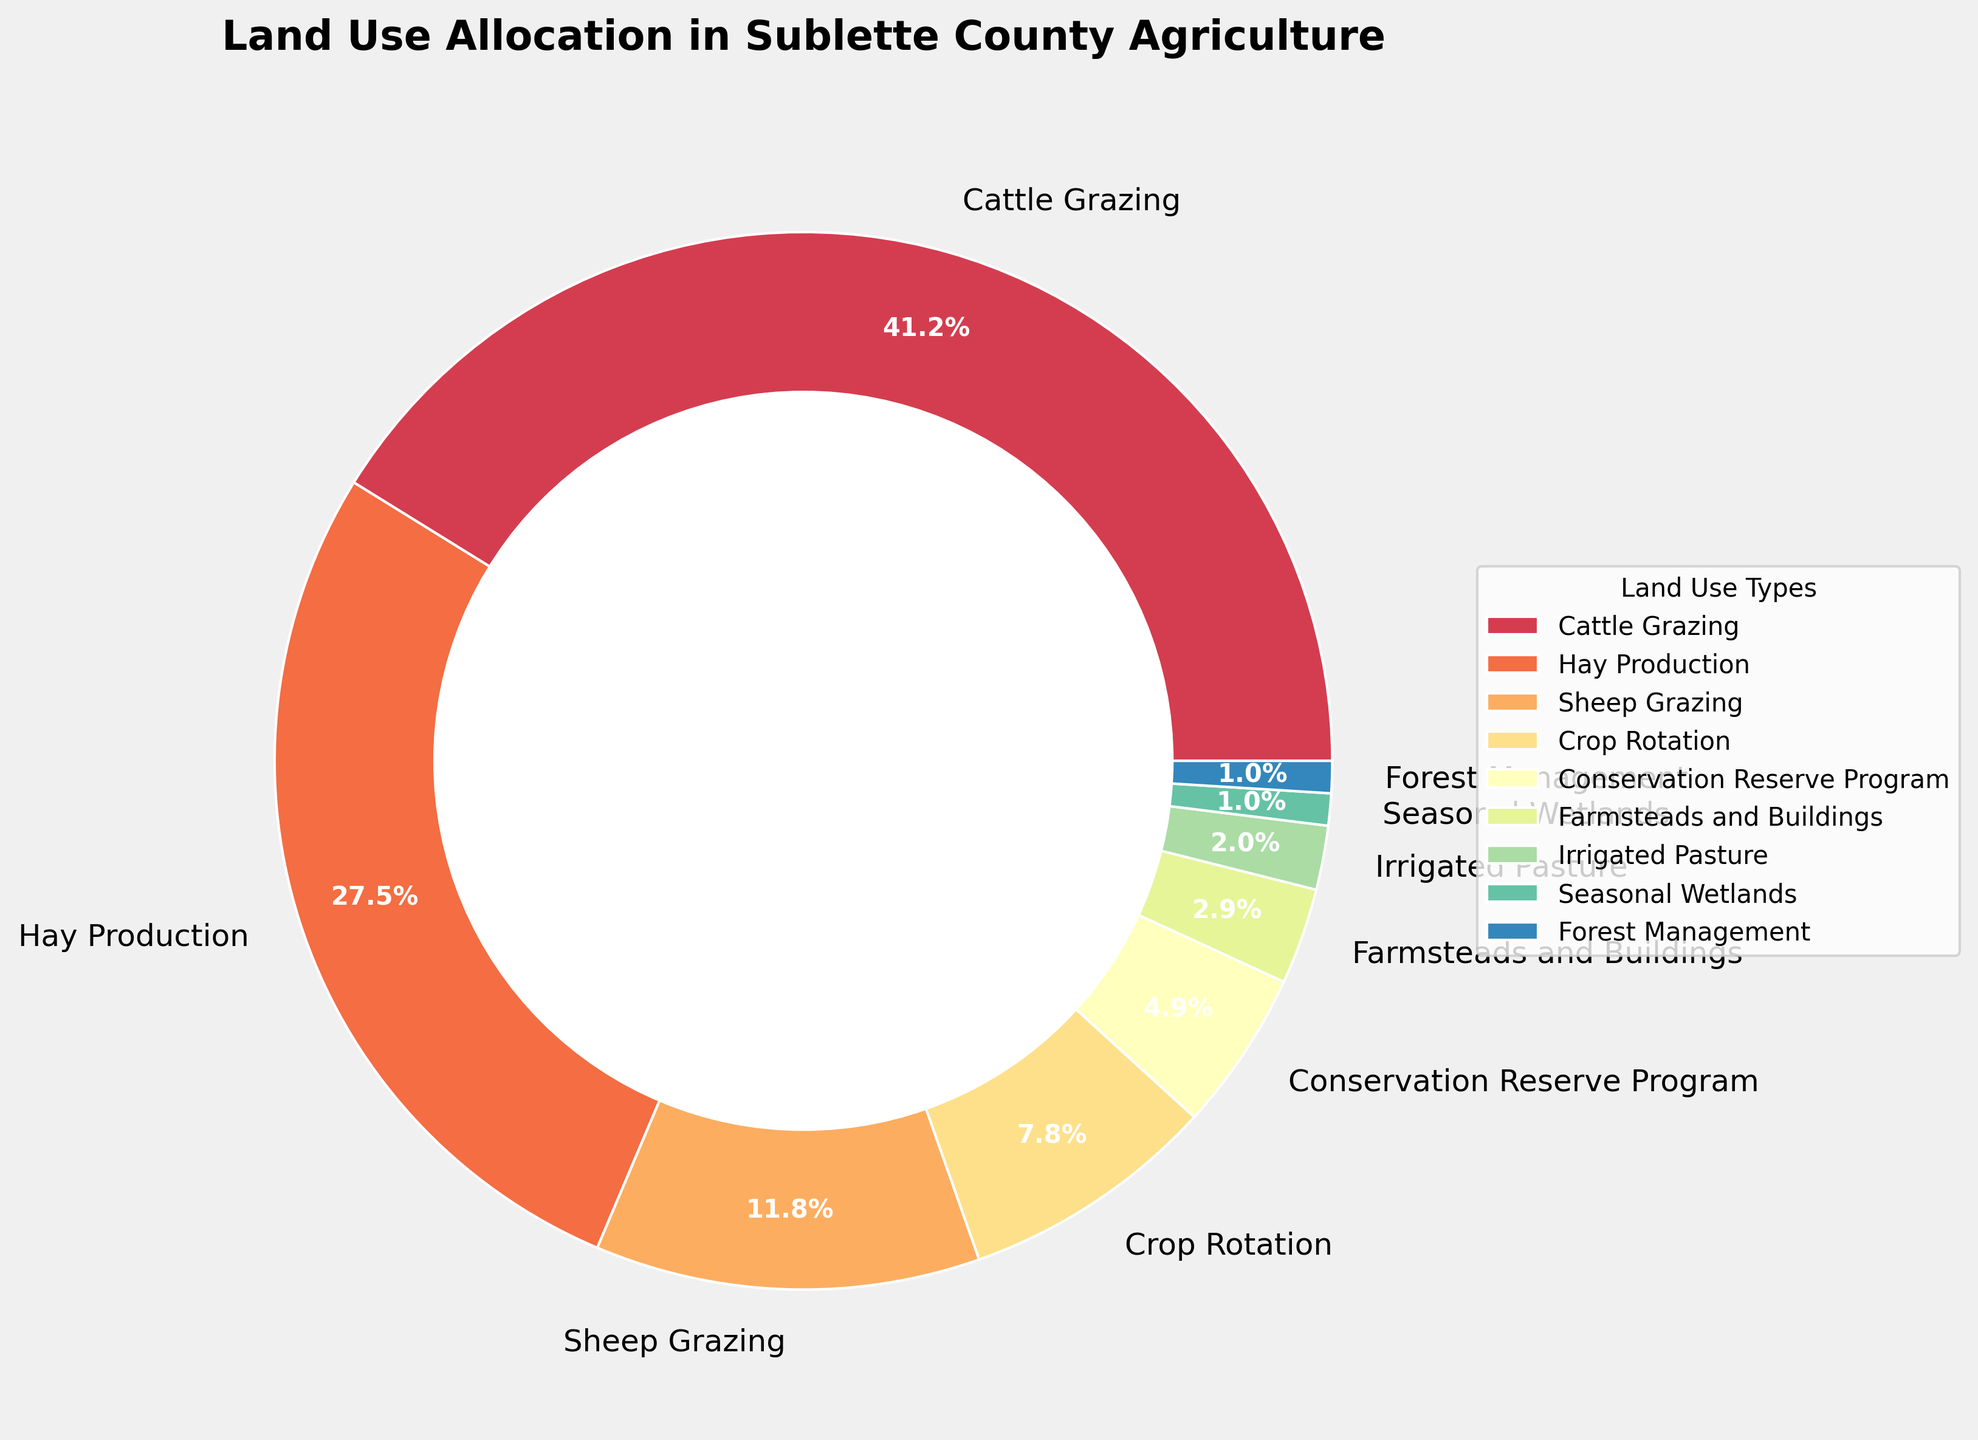Which land use type occupies the largest percentage of land in Sublette County agriculture? By looking at the pie chart, the largest wedge represents Cattle Grazing. The percentage label reads 42%, which is the highest among all.
Answer: Cattle Grazing How much more percentage of land is used for Cattle Grazing than Hay Production? Identify the percentages for both Cattle Grazing (42%) and Hay Production (28%) on the pie chart. Subtract the latter from the former: 42% - 28% = 14%.
Answer: 14% What is the combined percentage of land used for Sheep Grazing, Crop Rotation, and Conservation Reserve Program? Identify the percentages for Sheep Grazing (12%), Crop Rotation (8%), and Conservation Reserve Program (5%). Add them together: 12% + 8% + 5% = 25%.
Answer: 25% Is the percentage of land used for Hay Production greater than the combined percentage of Sheep Grazing and Crop Rotation? Identify the percentages for Hay Production (28%), Sheep Grazing (12%), and Crop Rotation (8%). Add the latter two: 12% + 8% = 20%. Compare 28% and 20%: 28% > 20%.
Answer: Yes Which land use type has the smallest allocation, and what is its percentage? Looking at the pie chart, the smallest wedge represents both Seasonal Wetlands and Forest Management. Each has a percentage label of 1%.
Answer: Seasonal Wetlands and Forest Management, 1% What is the total land use percentage represented by Irrigated Pasture, Seasonal Wetlands, and Forest Management? Identify the percentages for Irrigated Pasture (2%), Seasonal Wetlands (1%), and Forest Management (1%). Add them together: 2% + 1% + 1% = 4%.
Answer: 4% How does the use of land for Conservation Reserve Program compare to that for Farmsteads and Buildings in terms of percentage? Identify the percentages for Conservation Reserve Program (5%) and Farmsteads and Buildings (3%). Compare the values: 5% > 3%.
Answer: Greater by 2% Which land use type occupies just over a quarter of the land? Identify the percentage for each land use type from the pie chart. The wedge labeled Hay Production represents 28%, just over a quarter (25%).
Answer: Hay Production What percentage of land does Crop Rotation and Irrigated Pasture together occupy? Identify the percentages for Crop Rotation (8%) and Irrigated Pasture (2%). Add them together: 8% + 2% = 10%.
Answer: 10% Is the use of land for Cattle Grazing more than double the use for Sheep Grazing? Identify the percentages for Cattle Grazing (42%) and Sheep Grazing (12%). Check if 42% is more than twice 12%: 42% > 24%.
Answer: Yes 